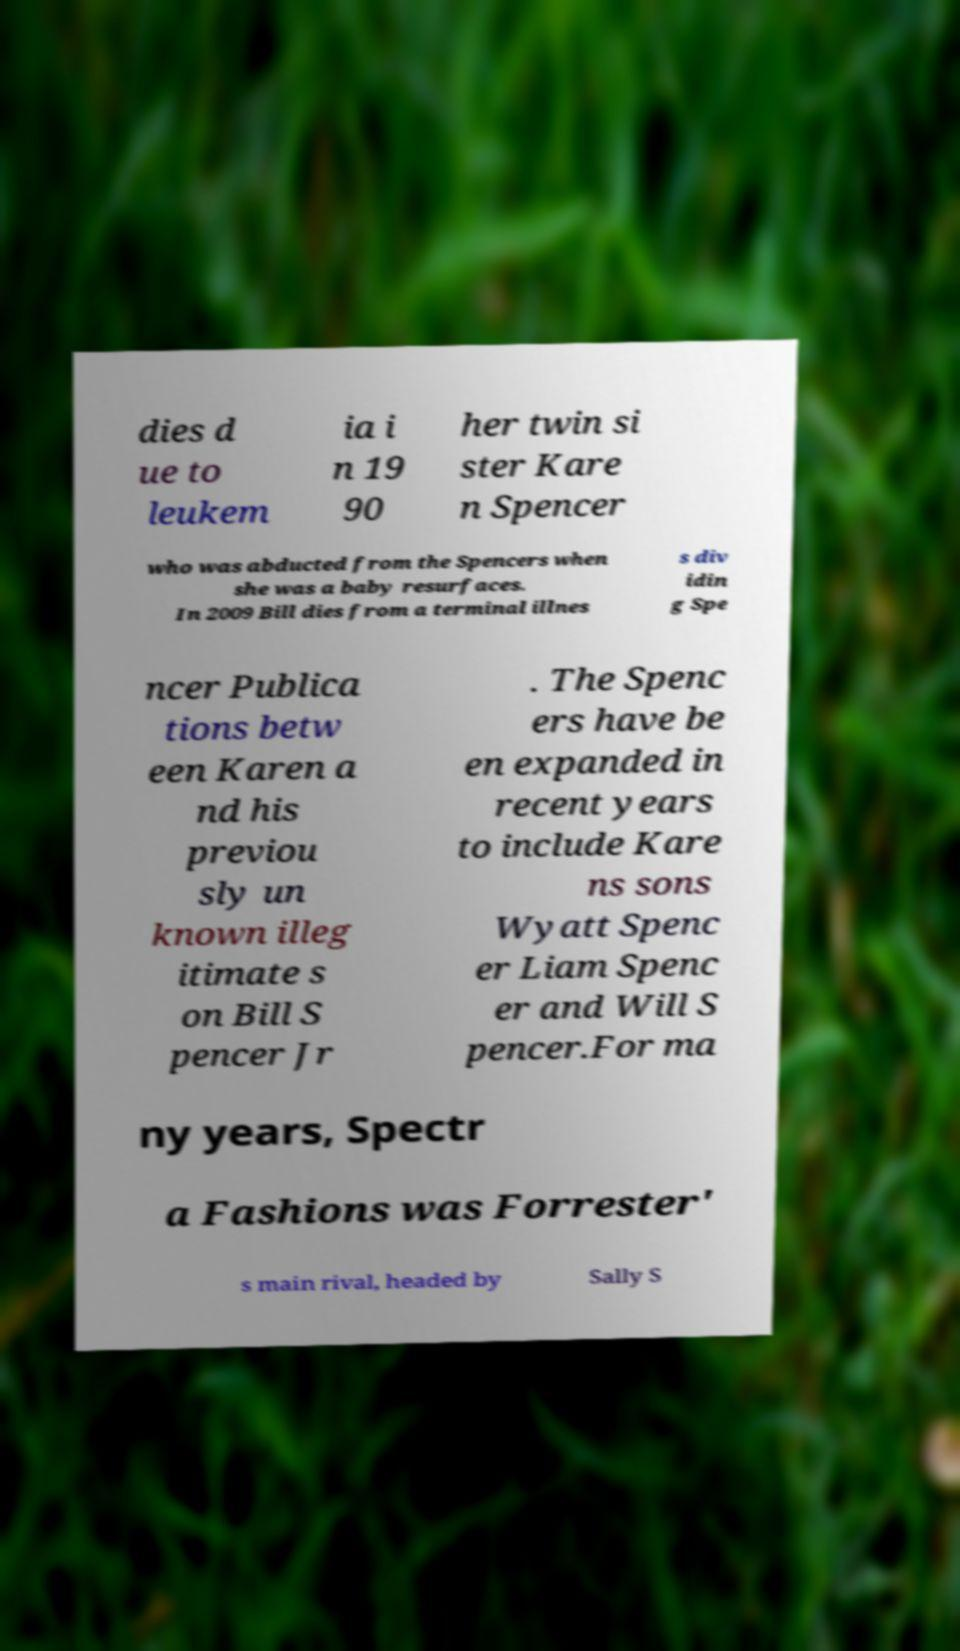Can you read and provide the text displayed in the image?This photo seems to have some interesting text. Can you extract and type it out for me? dies d ue to leukem ia i n 19 90 her twin si ster Kare n Spencer who was abducted from the Spencers when she was a baby resurfaces. In 2009 Bill dies from a terminal illnes s div idin g Spe ncer Publica tions betw een Karen a nd his previou sly un known illeg itimate s on Bill S pencer Jr . The Spenc ers have be en expanded in recent years to include Kare ns sons Wyatt Spenc er Liam Spenc er and Will S pencer.For ma ny years, Spectr a Fashions was Forrester' s main rival, headed by Sally S 